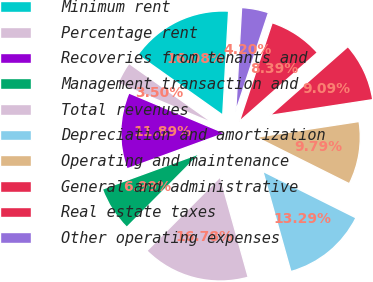Convert chart. <chart><loc_0><loc_0><loc_500><loc_500><pie_chart><fcel>Minimum rent<fcel>Percentage rent<fcel>Recoveries from tenants and<fcel>Management transaction and<fcel>Total revenues<fcel>Depreciation and amortization<fcel>Operating and maintenance<fcel>General and administrative<fcel>Real estate taxes<fcel>Other operating expenses<nl><fcel>16.08%<fcel>3.5%<fcel>11.89%<fcel>6.99%<fcel>16.78%<fcel>13.29%<fcel>9.79%<fcel>9.09%<fcel>8.39%<fcel>4.2%<nl></chart> 